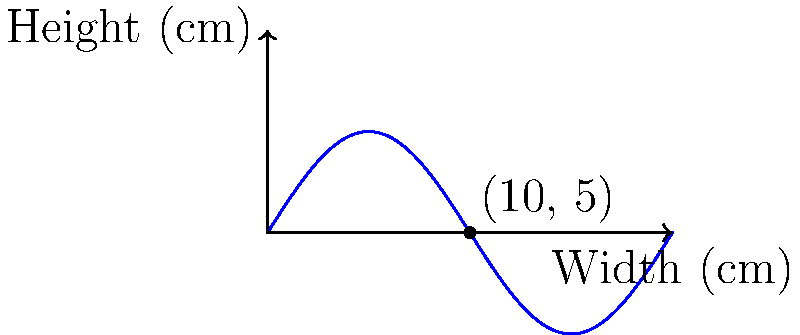An ancient amphora's profile can be approximated by rotating the curve $y = 5\sin(\frac{\pi x}{10})$ around the y-axis, where x and y are measured in centimeters. If the amphora has a height of 20 cm, estimate its volume to the nearest 100 cm³. To estimate the volume of the amphora, we'll use the washer method of integration:

1) The volume is given by the formula:
   $$V = \pi \int_0^{20} [f(x)]^2 dx$$
   where $f(x) = 5\sin(\frac{\pi x}{10})$

2) Substituting the function:
   $$V = \pi \int_0^{20} [5\sin(\frac{\pi x}{10})]^2 dx$$

3) Simplify:
   $$V = 25\pi \int_0^{20} \sin^2(\frac{\pi x}{10}) dx$$

4) Use the identity $\sin^2 x = \frac{1 - \cos 2x}{2}$:
   $$V = 25\pi \int_0^{20} \frac{1 - \cos(\frac{\pi x}{5})}{2} dx$$

5) Integrate:
   $$V = 25\pi [\frac{x}{2} - \frac{5}{\pi}\sin(\frac{\pi x}{5})]_0^{20}$$

6) Evaluate the limits:
   $$V = 25\pi [10 - \frac{5}{\pi}\sin(4\pi) - (0 - 0)]$$
   $$V = 250\pi$$

7) Calculate:
   $$V \approx 785.4 \text{ cm}^3$$

8) Rounding to the nearest 100 cm³:
   $$V \approx 800 \text{ cm}^3$$
Answer: 800 cm³ 